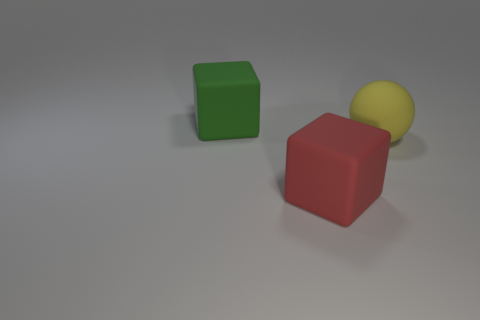Do the rubber object in front of the yellow object and the matte object right of the red matte cube have the same shape?
Ensure brevity in your answer.  No. Is the number of large spheres on the left side of the large yellow matte ball less than the number of large green shiny cylinders?
Offer a terse response. No. How big is the block in front of the big green matte cube?
Your answer should be compact. Large. The large rubber object that is right of the block that is in front of the block that is left of the large red block is what shape?
Your answer should be very brief. Sphere. What is the shape of the large rubber object that is on the left side of the yellow ball and behind the red matte block?
Offer a terse response. Cube. Are there any green objects that have the same size as the yellow matte object?
Provide a short and direct response. Yes. Does the big green matte thing behind the large ball have the same shape as the yellow matte thing?
Give a very brief answer. No. Is the green thing the same shape as the large red matte object?
Ensure brevity in your answer.  Yes. Are there any other things of the same shape as the green thing?
Provide a short and direct response. Yes. There is a big rubber thing in front of the thing on the right side of the red matte cube; what is its shape?
Keep it short and to the point. Cube. 